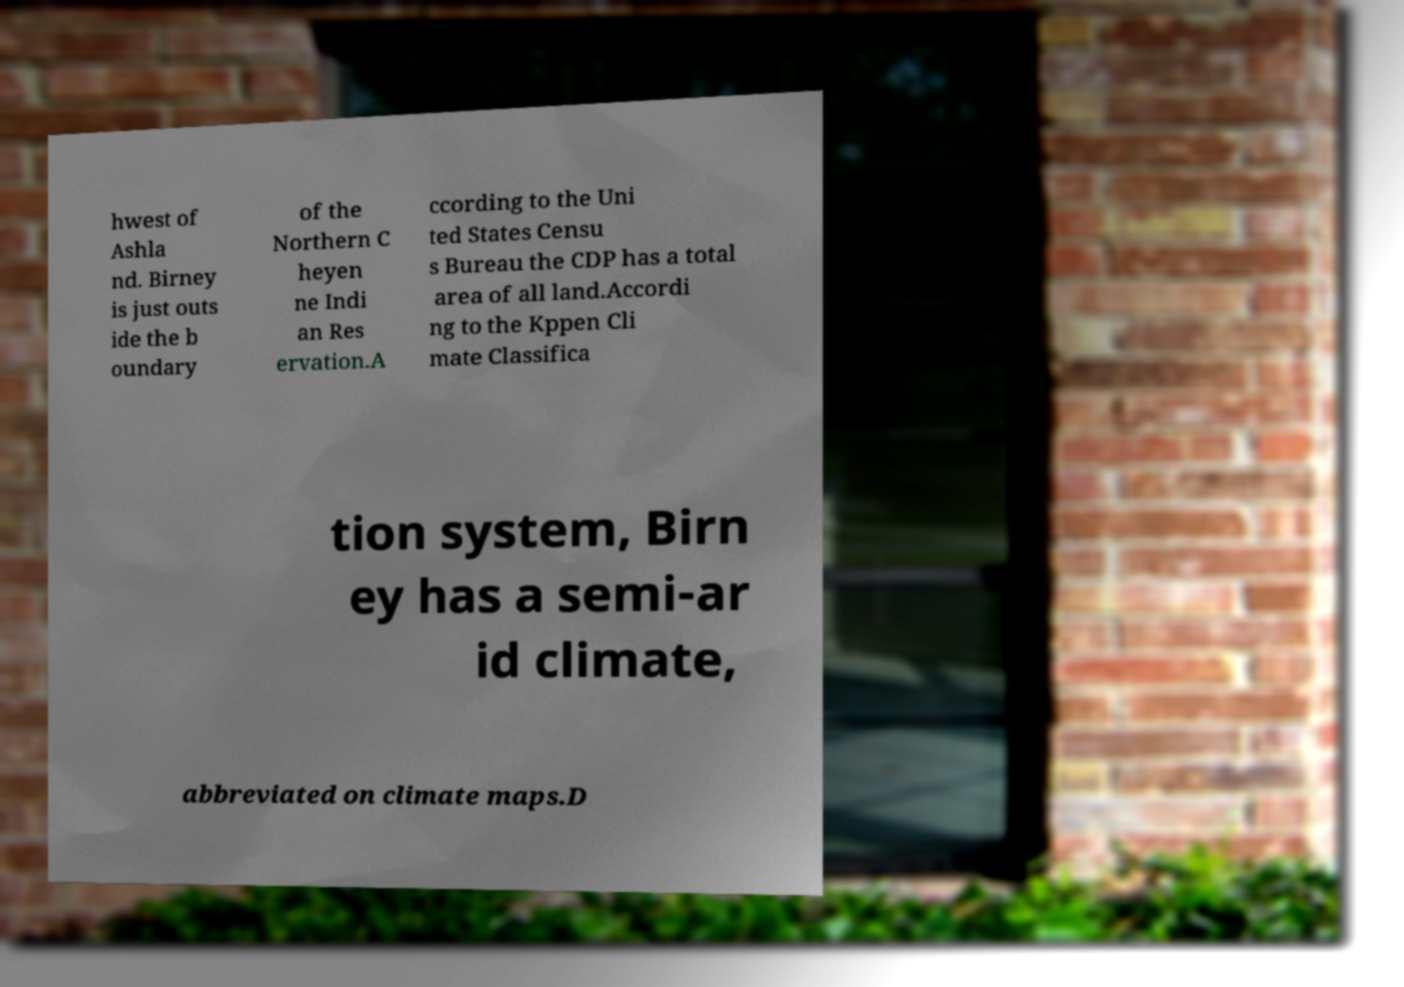What messages or text are displayed in this image? I need them in a readable, typed format. hwest of Ashla nd. Birney is just outs ide the b oundary of the Northern C heyen ne Indi an Res ervation.A ccording to the Uni ted States Censu s Bureau the CDP has a total area of all land.Accordi ng to the Kppen Cli mate Classifica tion system, Birn ey has a semi-ar id climate, abbreviated on climate maps.D 